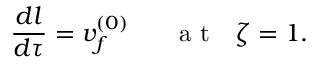<formula> <loc_0><loc_0><loc_500><loc_500>\frac { d l } { d \tau } = v _ { f } ^ { ( 0 ) } a t \zeta = 1 .</formula> 